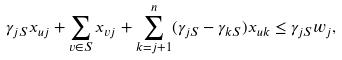Convert formula to latex. <formula><loc_0><loc_0><loc_500><loc_500>\gamma _ { j S } x _ { u j } + \sum _ { v \in S } x _ { v j } + \sum _ { k = j + 1 } ^ { n } ( \gamma _ { j S } - \gamma _ { k S } ) x _ { u k } \leq \gamma _ { j S } w _ { j } ,</formula> 